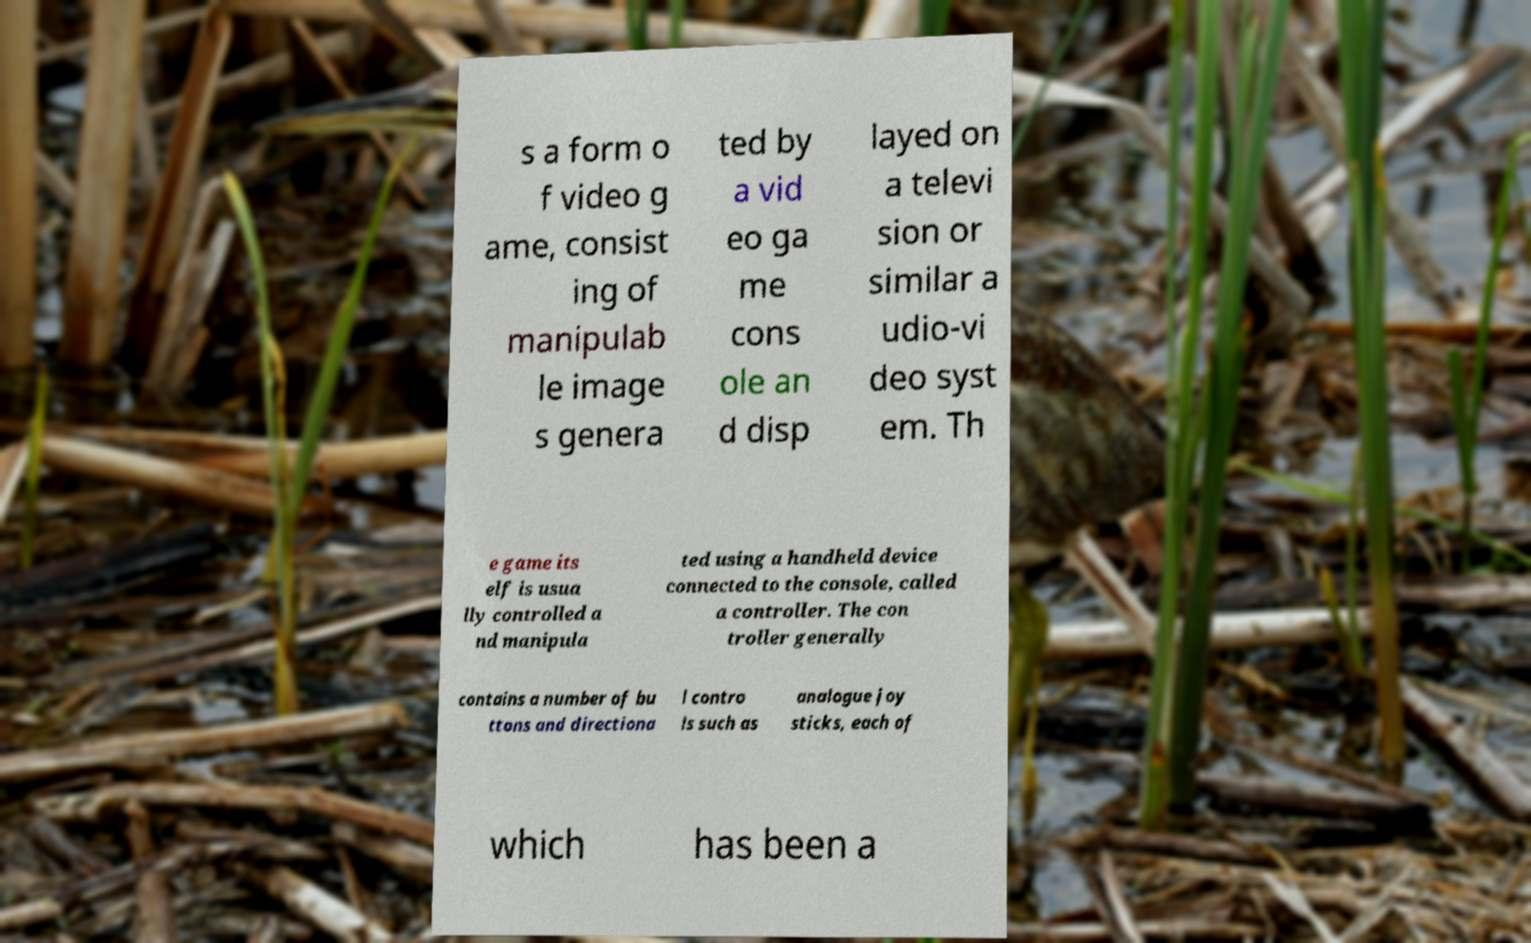What messages or text are displayed in this image? I need them in a readable, typed format. s a form o f video g ame, consist ing of manipulab le image s genera ted by a vid eo ga me cons ole an d disp layed on a televi sion or similar a udio-vi deo syst em. Th e game its elf is usua lly controlled a nd manipula ted using a handheld device connected to the console, called a controller. The con troller generally contains a number of bu ttons and directiona l contro ls such as analogue joy sticks, each of which has been a 